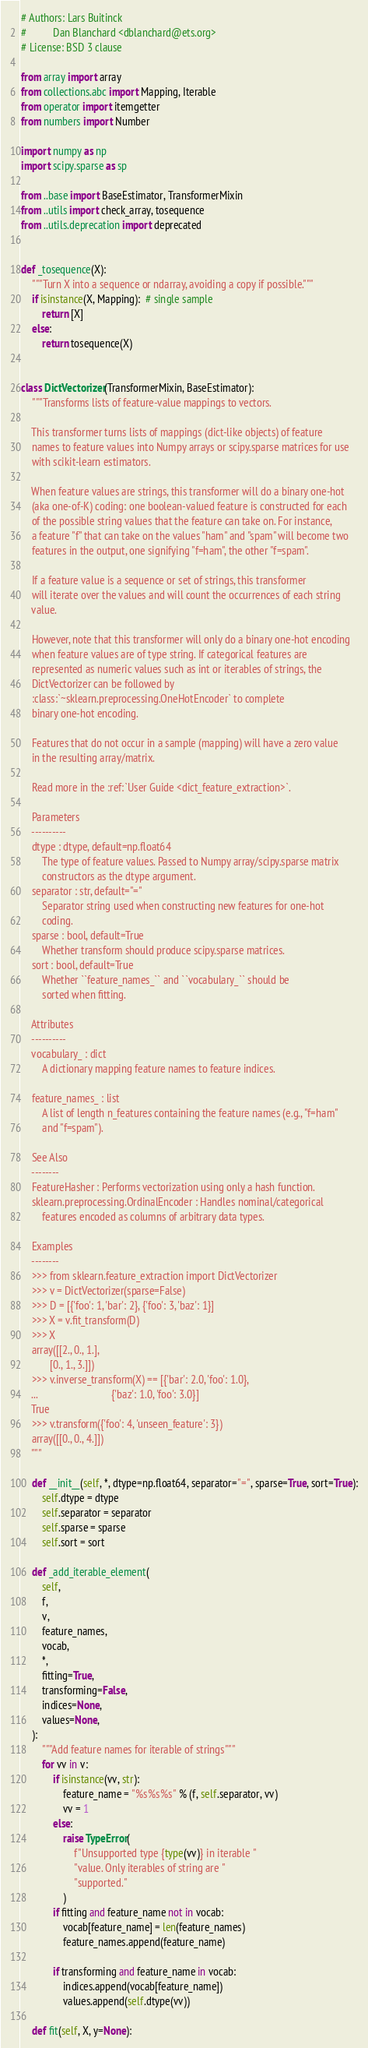<code> <loc_0><loc_0><loc_500><loc_500><_Python_># Authors: Lars Buitinck
#          Dan Blanchard <dblanchard@ets.org>
# License: BSD 3 clause

from array import array
from collections.abc import Mapping, Iterable
from operator import itemgetter
from numbers import Number

import numpy as np
import scipy.sparse as sp

from ..base import BaseEstimator, TransformerMixin
from ..utils import check_array, tosequence
from ..utils.deprecation import deprecated


def _tosequence(X):
    """Turn X into a sequence or ndarray, avoiding a copy if possible."""
    if isinstance(X, Mapping):  # single sample
        return [X]
    else:
        return tosequence(X)


class DictVectorizer(TransformerMixin, BaseEstimator):
    """Transforms lists of feature-value mappings to vectors.

    This transformer turns lists of mappings (dict-like objects) of feature
    names to feature values into Numpy arrays or scipy.sparse matrices for use
    with scikit-learn estimators.

    When feature values are strings, this transformer will do a binary one-hot
    (aka one-of-K) coding: one boolean-valued feature is constructed for each
    of the possible string values that the feature can take on. For instance,
    a feature "f" that can take on the values "ham" and "spam" will become two
    features in the output, one signifying "f=ham", the other "f=spam".

    If a feature value is a sequence or set of strings, this transformer
    will iterate over the values and will count the occurrences of each string
    value.

    However, note that this transformer will only do a binary one-hot encoding
    when feature values are of type string. If categorical features are
    represented as numeric values such as int or iterables of strings, the
    DictVectorizer can be followed by
    :class:`~sklearn.preprocessing.OneHotEncoder` to complete
    binary one-hot encoding.

    Features that do not occur in a sample (mapping) will have a zero value
    in the resulting array/matrix.

    Read more in the :ref:`User Guide <dict_feature_extraction>`.

    Parameters
    ----------
    dtype : dtype, default=np.float64
        The type of feature values. Passed to Numpy array/scipy.sparse matrix
        constructors as the dtype argument.
    separator : str, default="="
        Separator string used when constructing new features for one-hot
        coding.
    sparse : bool, default=True
        Whether transform should produce scipy.sparse matrices.
    sort : bool, default=True
        Whether ``feature_names_`` and ``vocabulary_`` should be
        sorted when fitting.

    Attributes
    ----------
    vocabulary_ : dict
        A dictionary mapping feature names to feature indices.

    feature_names_ : list
        A list of length n_features containing the feature names (e.g., "f=ham"
        and "f=spam").

    See Also
    --------
    FeatureHasher : Performs vectorization using only a hash function.
    sklearn.preprocessing.OrdinalEncoder : Handles nominal/categorical
        features encoded as columns of arbitrary data types.

    Examples
    --------
    >>> from sklearn.feature_extraction import DictVectorizer
    >>> v = DictVectorizer(sparse=False)
    >>> D = [{'foo': 1, 'bar': 2}, {'foo': 3, 'baz': 1}]
    >>> X = v.fit_transform(D)
    >>> X
    array([[2., 0., 1.],
           [0., 1., 3.]])
    >>> v.inverse_transform(X) == [{'bar': 2.0, 'foo': 1.0},
    ...                            {'baz': 1.0, 'foo': 3.0}]
    True
    >>> v.transform({'foo': 4, 'unseen_feature': 3})
    array([[0., 0., 4.]])
    """

    def __init__(self, *, dtype=np.float64, separator="=", sparse=True, sort=True):
        self.dtype = dtype
        self.separator = separator
        self.sparse = sparse
        self.sort = sort

    def _add_iterable_element(
        self,
        f,
        v,
        feature_names,
        vocab,
        *,
        fitting=True,
        transforming=False,
        indices=None,
        values=None,
    ):
        """Add feature names for iterable of strings"""
        for vv in v:
            if isinstance(vv, str):
                feature_name = "%s%s%s" % (f, self.separator, vv)
                vv = 1
            else:
                raise TypeError(
                    f"Unsupported type {type(vv)} in iterable "
                    "value. Only iterables of string are "
                    "supported."
                )
            if fitting and feature_name not in vocab:
                vocab[feature_name] = len(feature_names)
                feature_names.append(feature_name)

            if transforming and feature_name in vocab:
                indices.append(vocab[feature_name])
                values.append(self.dtype(vv))

    def fit(self, X, y=None):</code> 